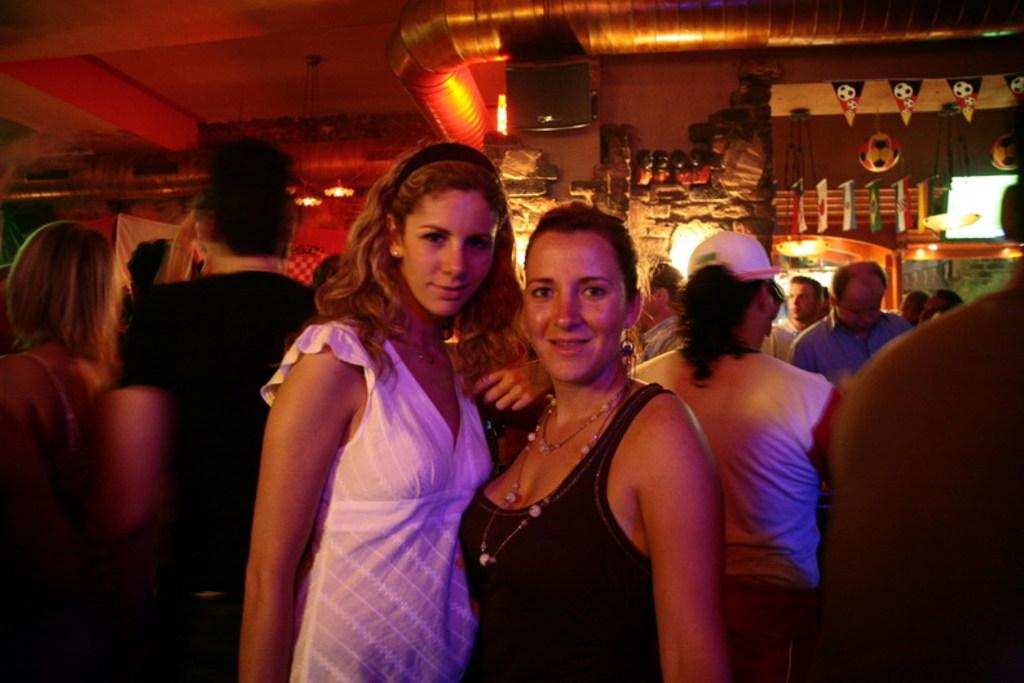What is happening in the image? There are people standing in the image. What can be seen at the top of the image? There is a duct visible at the top of the image. What else is present in the image besides the people? There are some objects in the image. What type of yarn is being used in the library in the image? There is no yarn or library present in the image. How many bottles can be seen on the table in the image? There is no table or bottles present in the image. 